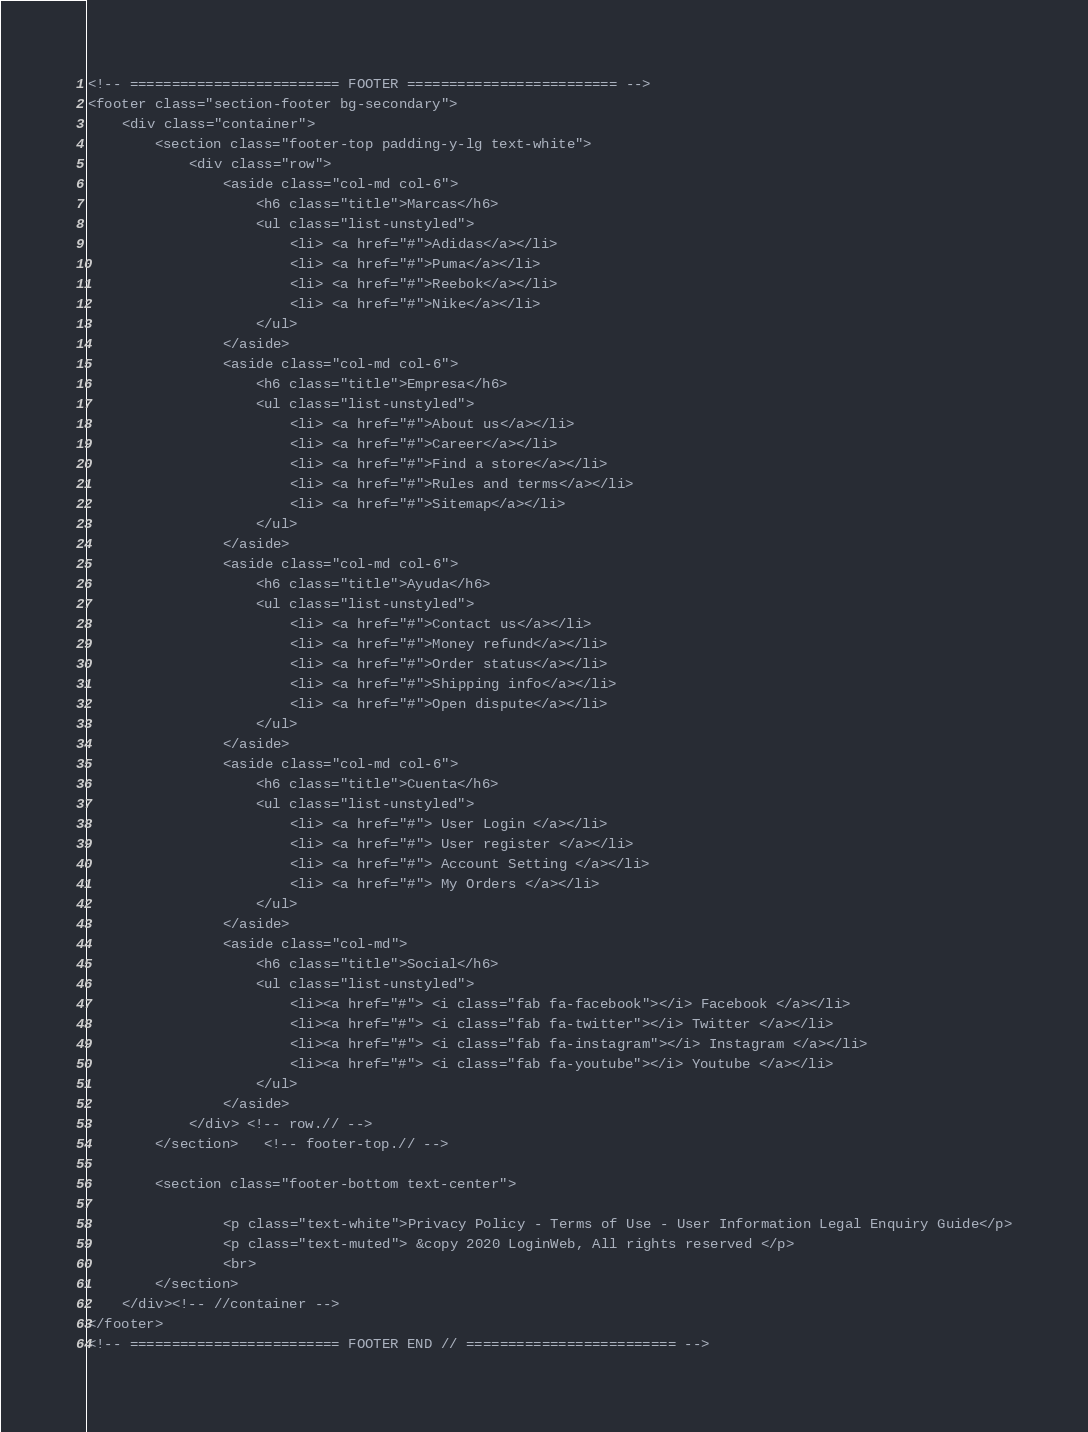Convert code to text. <code><loc_0><loc_0><loc_500><loc_500><_PHP_><!-- ========================= FOOTER ========================= -->
<footer class="section-footer bg-secondary">
    <div class="container">
        <section class="footer-top padding-y-lg text-white">
            <div class="row">
                <aside class="col-md col-6">
                    <h6 class="title">Marcas</h6>
                    <ul class="list-unstyled">
                        <li> <a href="#">Adidas</a></li>
                        <li> <a href="#">Puma</a></li>
                        <li> <a href="#">Reebok</a></li>
                        <li> <a href="#">Nike</a></li>
                    </ul>
                </aside>
                <aside class="col-md col-6">
                    <h6 class="title">Empresa</h6>
                    <ul class="list-unstyled">
                        <li> <a href="#">About us</a></li>
                        <li> <a href="#">Career</a></li>
                        <li> <a href="#">Find a store</a></li>
                        <li> <a href="#">Rules and terms</a></li>
                        <li> <a href="#">Sitemap</a></li>
                    </ul>
                </aside>
                <aside class="col-md col-6">
                    <h6 class="title">Ayuda</h6>
                    <ul class="list-unstyled">
                        <li> <a href="#">Contact us</a></li>
                        <li> <a href="#">Money refund</a></li>
                        <li> <a href="#">Order status</a></li>
                        <li> <a href="#">Shipping info</a></li>
                        <li> <a href="#">Open dispute</a></li>
                    </ul>
                </aside>
                <aside class="col-md col-6">
                    <h6 class="title">Cuenta</h6>
                    <ul class="list-unstyled">
                        <li> <a href="#"> User Login </a></li>
                        <li> <a href="#"> User register </a></li>
                        <li> <a href="#"> Account Setting </a></li>
                        <li> <a href="#"> My Orders </a></li>
                    </ul>
                </aside>
                <aside class="col-md">
                    <h6 class="title">Social</h6>
                    <ul class="list-unstyled">
                        <li><a href="#"> <i class="fab fa-facebook"></i> Facebook </a></li>
                        <li><a href="#"> <i class="fab fa-twitter"></i> Twitter </a></li>
                        <li><a href="#"> <i class="fab fa-instagram"></i> Instagram </a></li>
                        <li><a href="#"> <i class="fab fa-youtube"></i> Youtube </a></li>
                    </ul>
                </aside>
            </div> <!-- row.// -->
        </section>	<!-- footer-top.// -->

        <section class="footer-bottom text-center">
        
                <p class="text-white">Privacy Policy - Terms of Use - User Information Legal Enquiry Guide</p>
                <p class="text-muted"> &copy 2020 LoginWeb, All rights reserved </p>
                <br>
        </section>
    </div><!-- //container -->
</footer>
<!-- ========================= FOOTER END // ========================= --></code> 